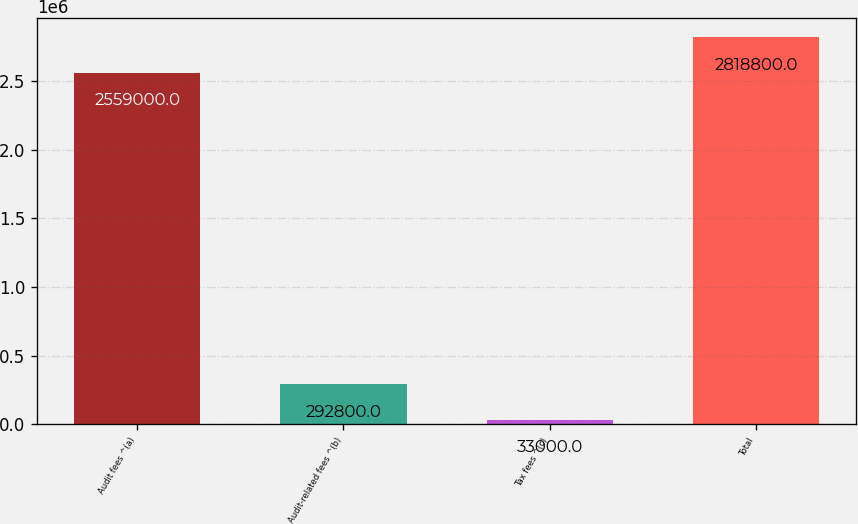Convert chart to OTSL. <chart><loc_0><loc_0><loc_500><loc_500><bar_chart><fcel>Audit fees ^(a)<fcel>Audit-related fees ^(b)<fcel>Tax fees ^(c)<fcel>Total<nl><fcel>2.559e+06<fcel>292800<fcel>33000<fcel>2.8188e+06<nl></chart> 